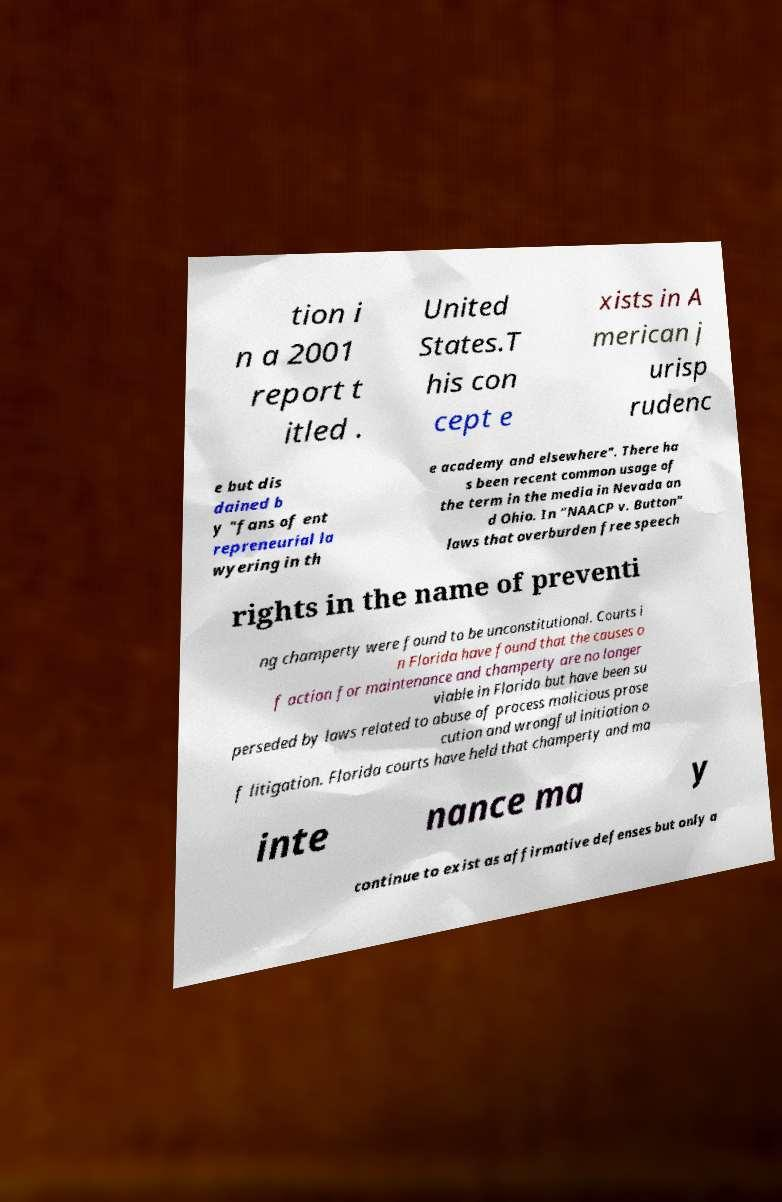Can you accurately transcribe the text from the provided image for me? tion i n a 2001 report t itled . United States.T his con cept e xists in A merican j urisp rudenc e but dis dained b y "fans of ent repreneurial la wyering in th e academy and elsewhere". There ha s been recent common usage of the term in the media in Nevada an d Ohio. In "NAACP v. Button" laws that overburden free speech rights in the name of preventi ng champerty were found to be unconstitutional. Courts i n Florida have found that the causes o f action for maintenance and champerty are no longer viable in Florida but have been su perseded by laws related to abuse of process malicious prose cution and wrongful initiation o f litigation. Florida courts have held that champerty and ma inte nance ma y continue to exist as affirmative defenses but only a 